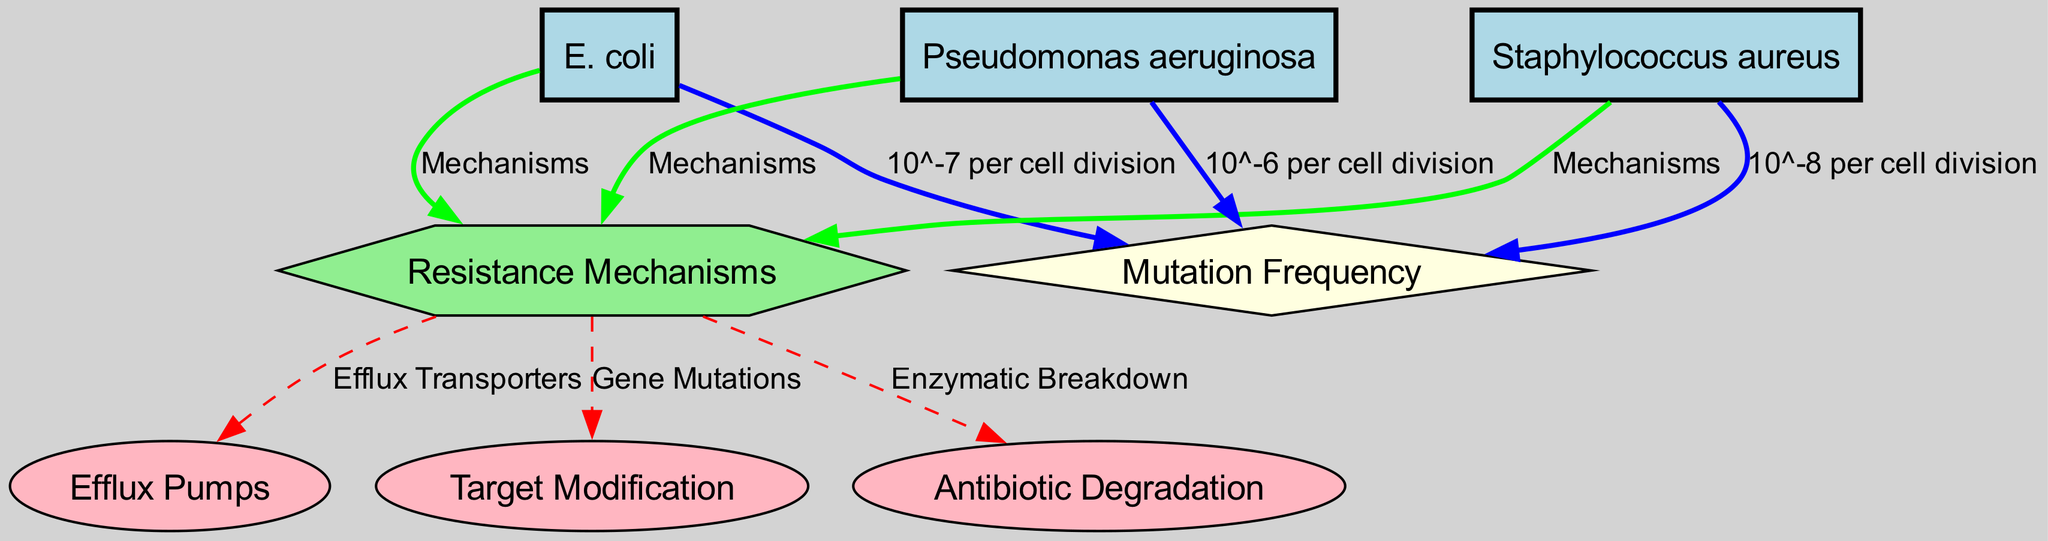What is the mutation frequency for E. coli? The diagram shows an edge from the node "E. coli" to the node "Mutation Frequency" labeled with "10^-7 per cell division." This indicates the specific mutation frequency associated with E. coli.
Answer: 10^-7 per cell division How many resistance mechanisms are identified in the diagram? The diagram includes a single node labeled "Resistance Mechanisms," which connects to three sub-nodes representing different mechanisms. Since these sub-nodes are directly linked to the "Resistance Mechanisms" node, they signify the specific mechanisms identified.
Answer: 3 Which bacterial species has the highest mutation frequency? By examining the edges leading to the "Mutation Frequency" node, we see that "Pseudomonas aeruginosa" is connected with the label "10^-6 per cell division," which is higher than both E. coli and Staphylococcus aureus.
Answer: Pseudomonas aeruginosa What are the resistance mechanisms linked to Staphylococcus aureus? The diagram connects "Staphylococcus aureus" to "Resistance Mechanisms," which further connects to three specific mechanisms: Efflux Pumps, Target Modification, and Antibiotic Degradation, indicating all are relevant for Staphylococcus aureus.
Answer: Efflux Pumps, Target Modification, Antibiotic Degradation How is antibiotic degradation categorized in the diagram? The node "Antibiotic Degradation" is connected to the "Resistance Mechanisms" node via a dashed edge, indicating a specific pathway that highlights it as one of the resistance mechanisms represented throughout the diagram.
Answer: Enzymatic Breakdown What is the relationship between mutation frequency and Pseudomonas aeruginosa? The diagram illustrates a direct edge from "Pseudomonas aeruginosa" to "Mutation Frequency" labeled "10^-6 per cell division," indicating that the mutation frequency for Pseudomonas aeruginosa is specifically quantified here.
Answer: 10^-6 per cell division Which edge type is used to represent the relationship between bacterial species and mutation frequency? The edges connecting bacterial species like E. coli, Staphylococcus aureus, and Pseudomonas aeruginosa to "Mutation Frequency" are colored blue and have a solid line style, indicating their specific quantitative relationship with mutation frequency.
Answer: Solid blue edge What is the role of efflux transporters according to the diagram? The diagram connects the "Resistance Mechanisms" node to the "Efflux Pumps" node with a solid edge, indicating that efflux transporters are a component under the resistance mechanisms for the bacteria represented.
Answer: Efflux Transporters What is the mutation frequency of Staphylococcus aureus? The diagram shows an edge from "Staphylococcus aureus" to "Mutation Frequency" labeled with "10^-8 per cell division," detailing its specific mutation frequency indicated in the diagram.
Answer: 10^-8 per cell division 